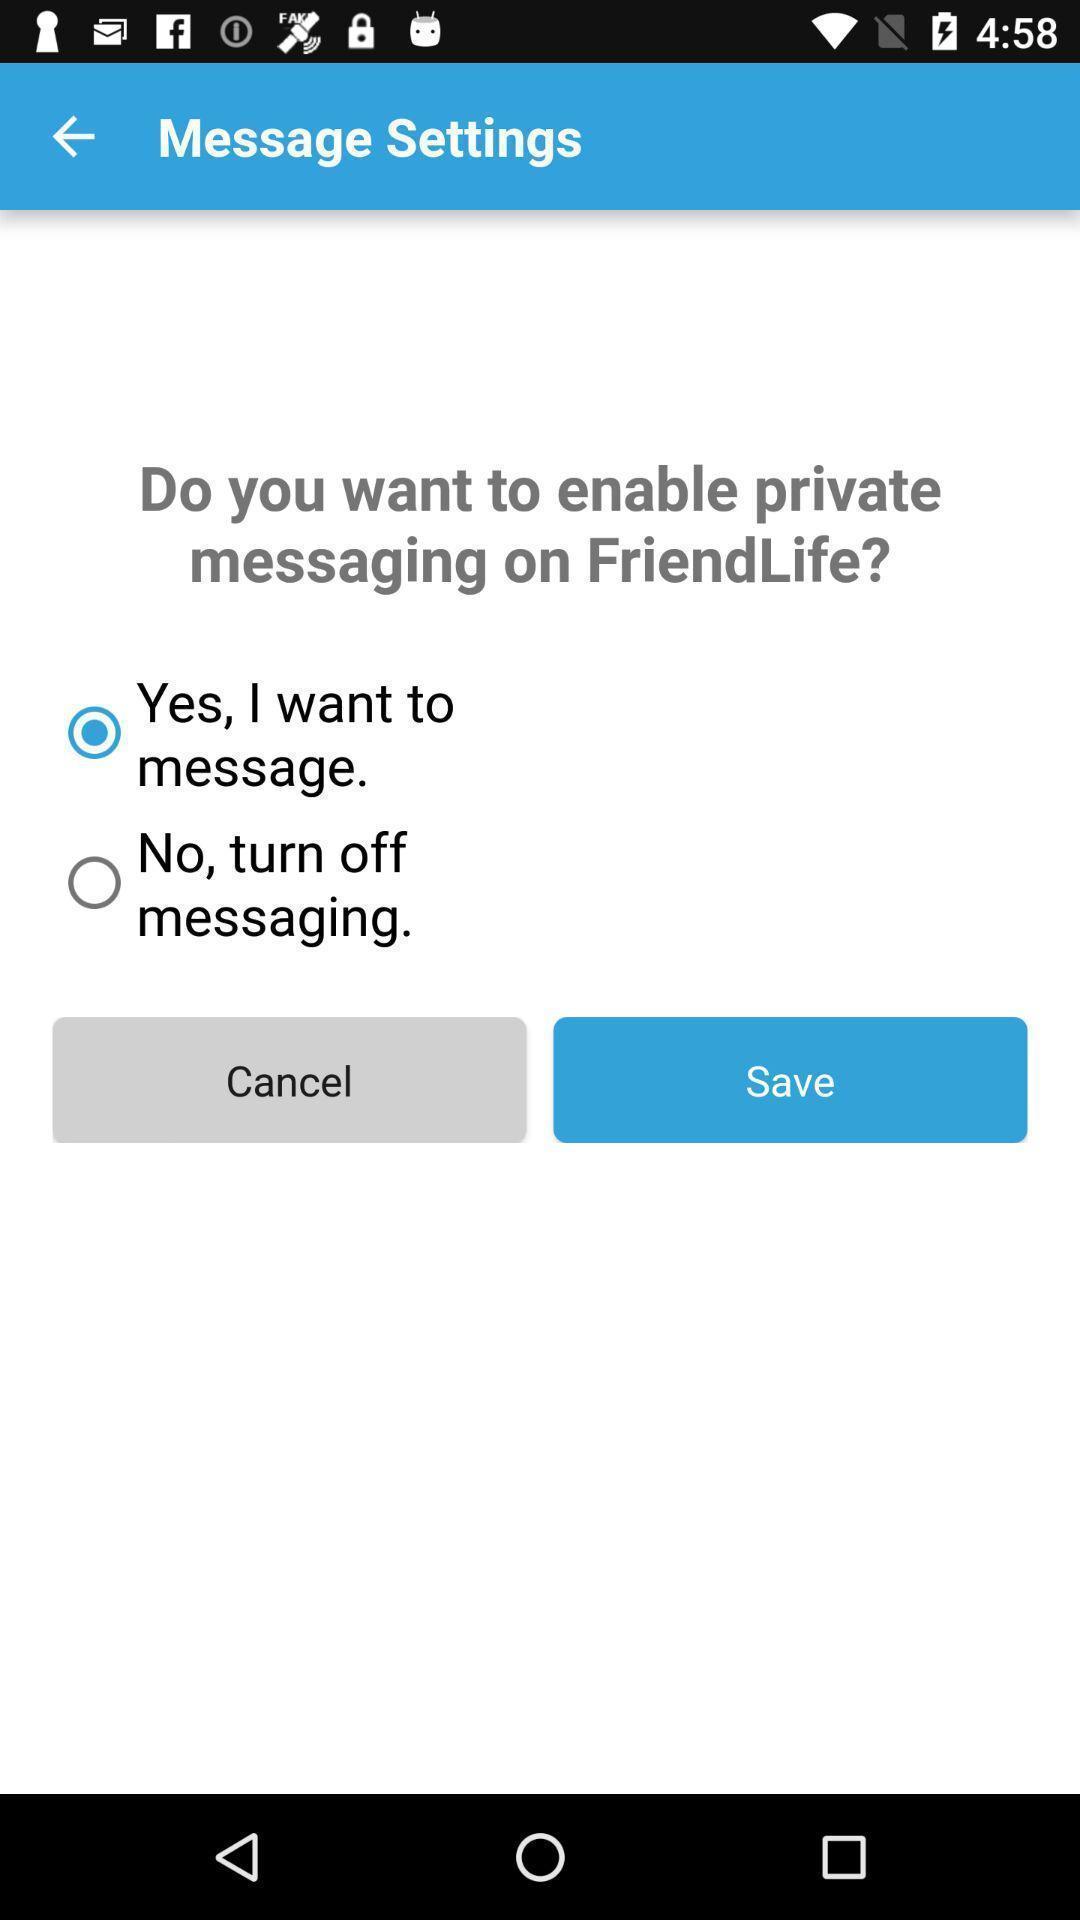What details can you identify in this image? Pop up message. 